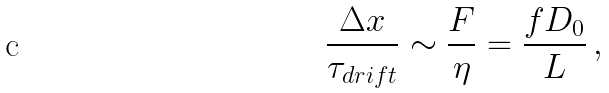Convert formula to latex. <formula><loc_0><loc_0><loc_500><loc_500>\frac { \Delta x } { \tau _ { d r i f t } } \sim \frac { F } { \eta } = \frac { f D _ { 0 } } { L } \, ,</formula> 